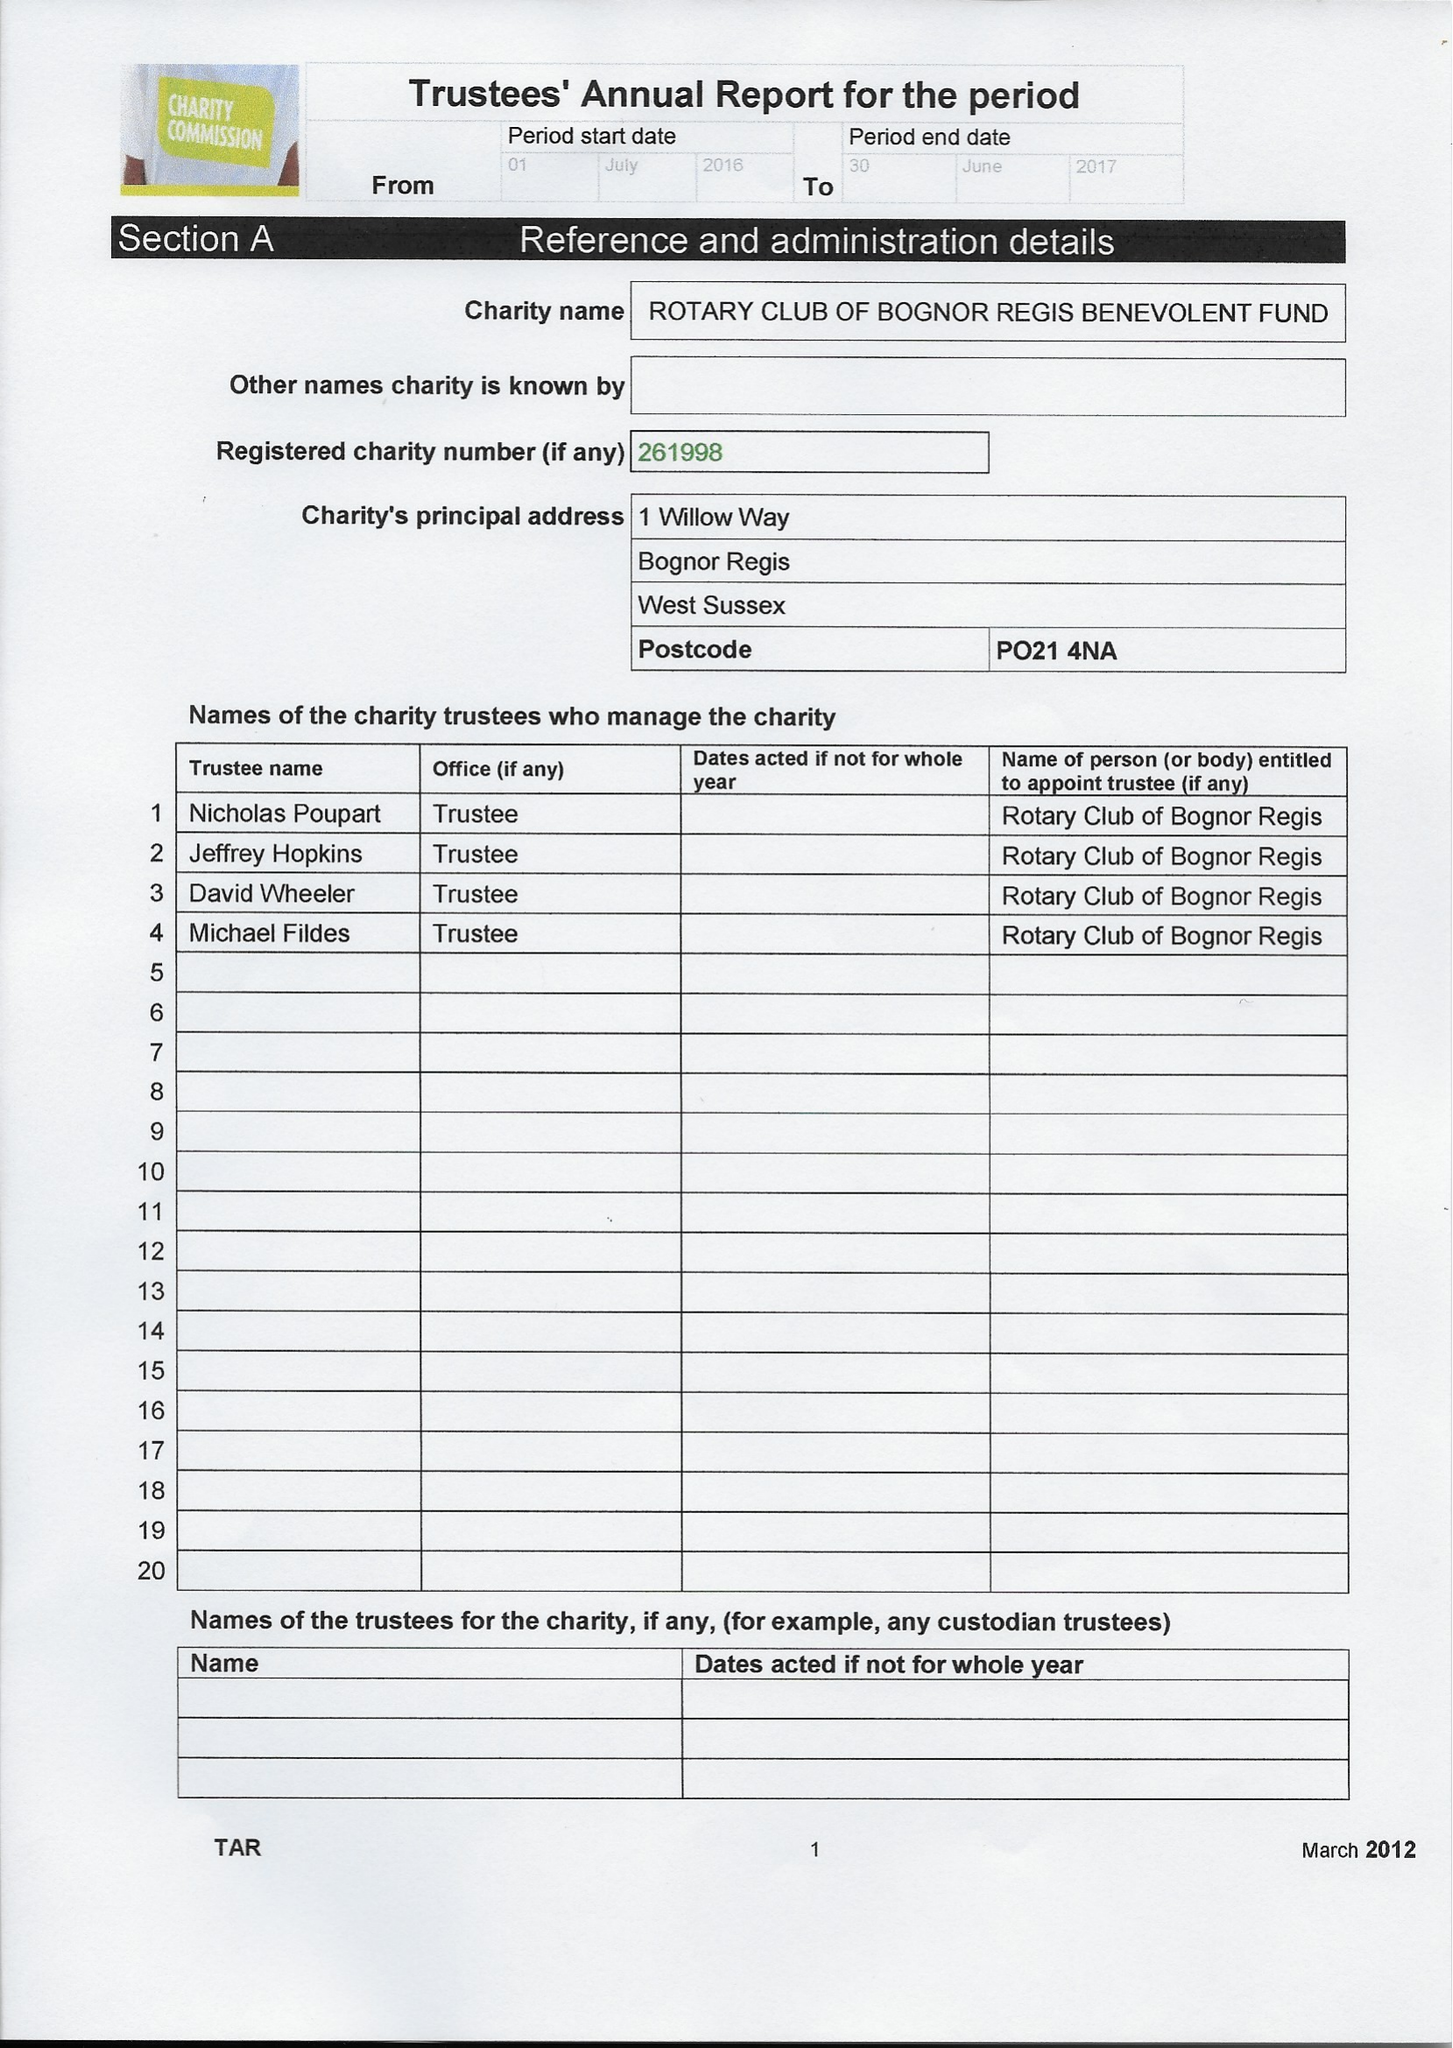What is the value for the spending_annually_in_british_pounds?
Answer the question using a single word or phrase. 16364.12 